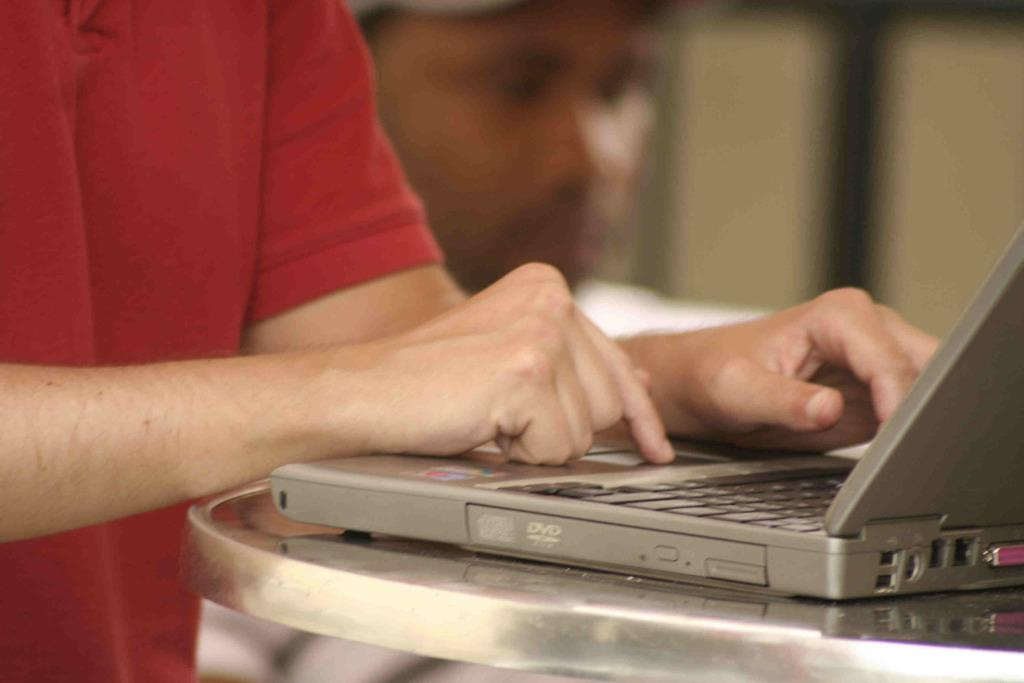Provide a one-sentence caption for the provided image. A man wearing a red shirt is typing on a silver computer near the DVD compartment. 